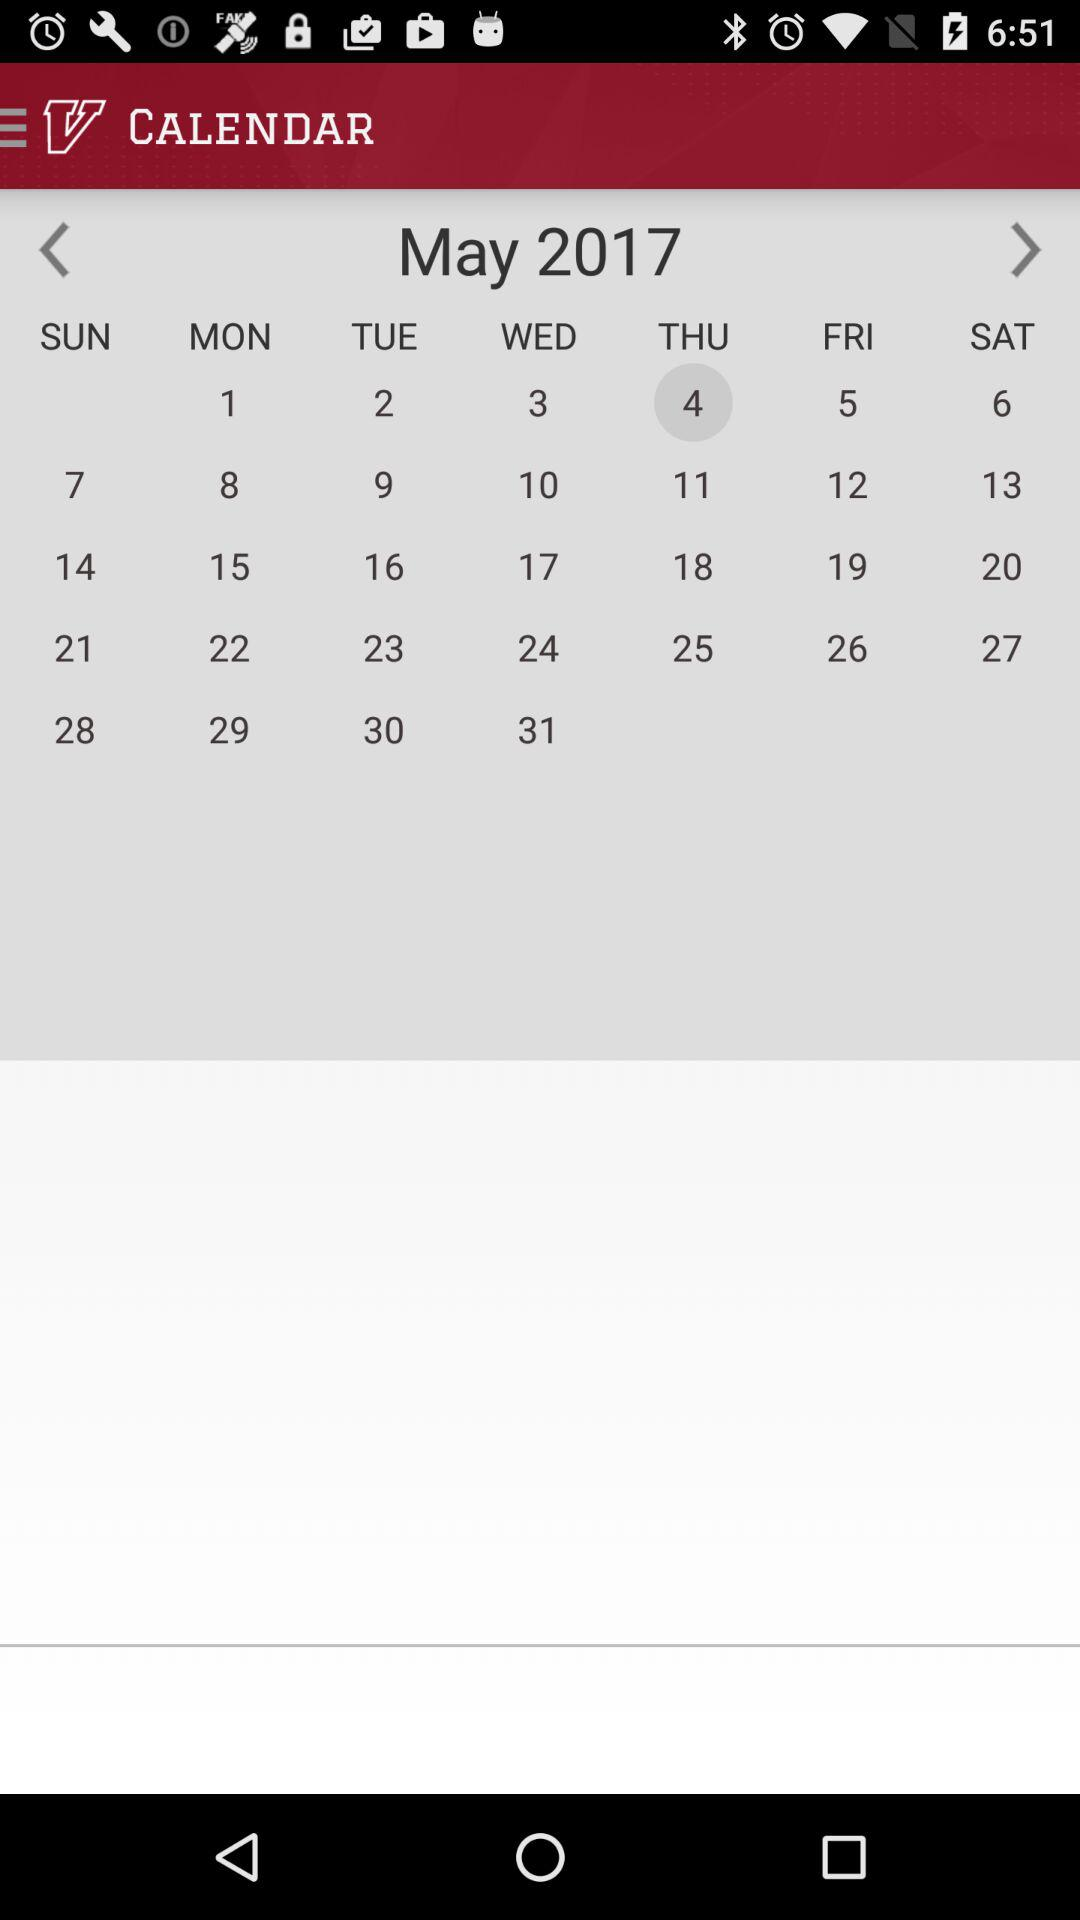What's the month & year presented in the calendar? The month and year presented in the calendar is May 2017. 